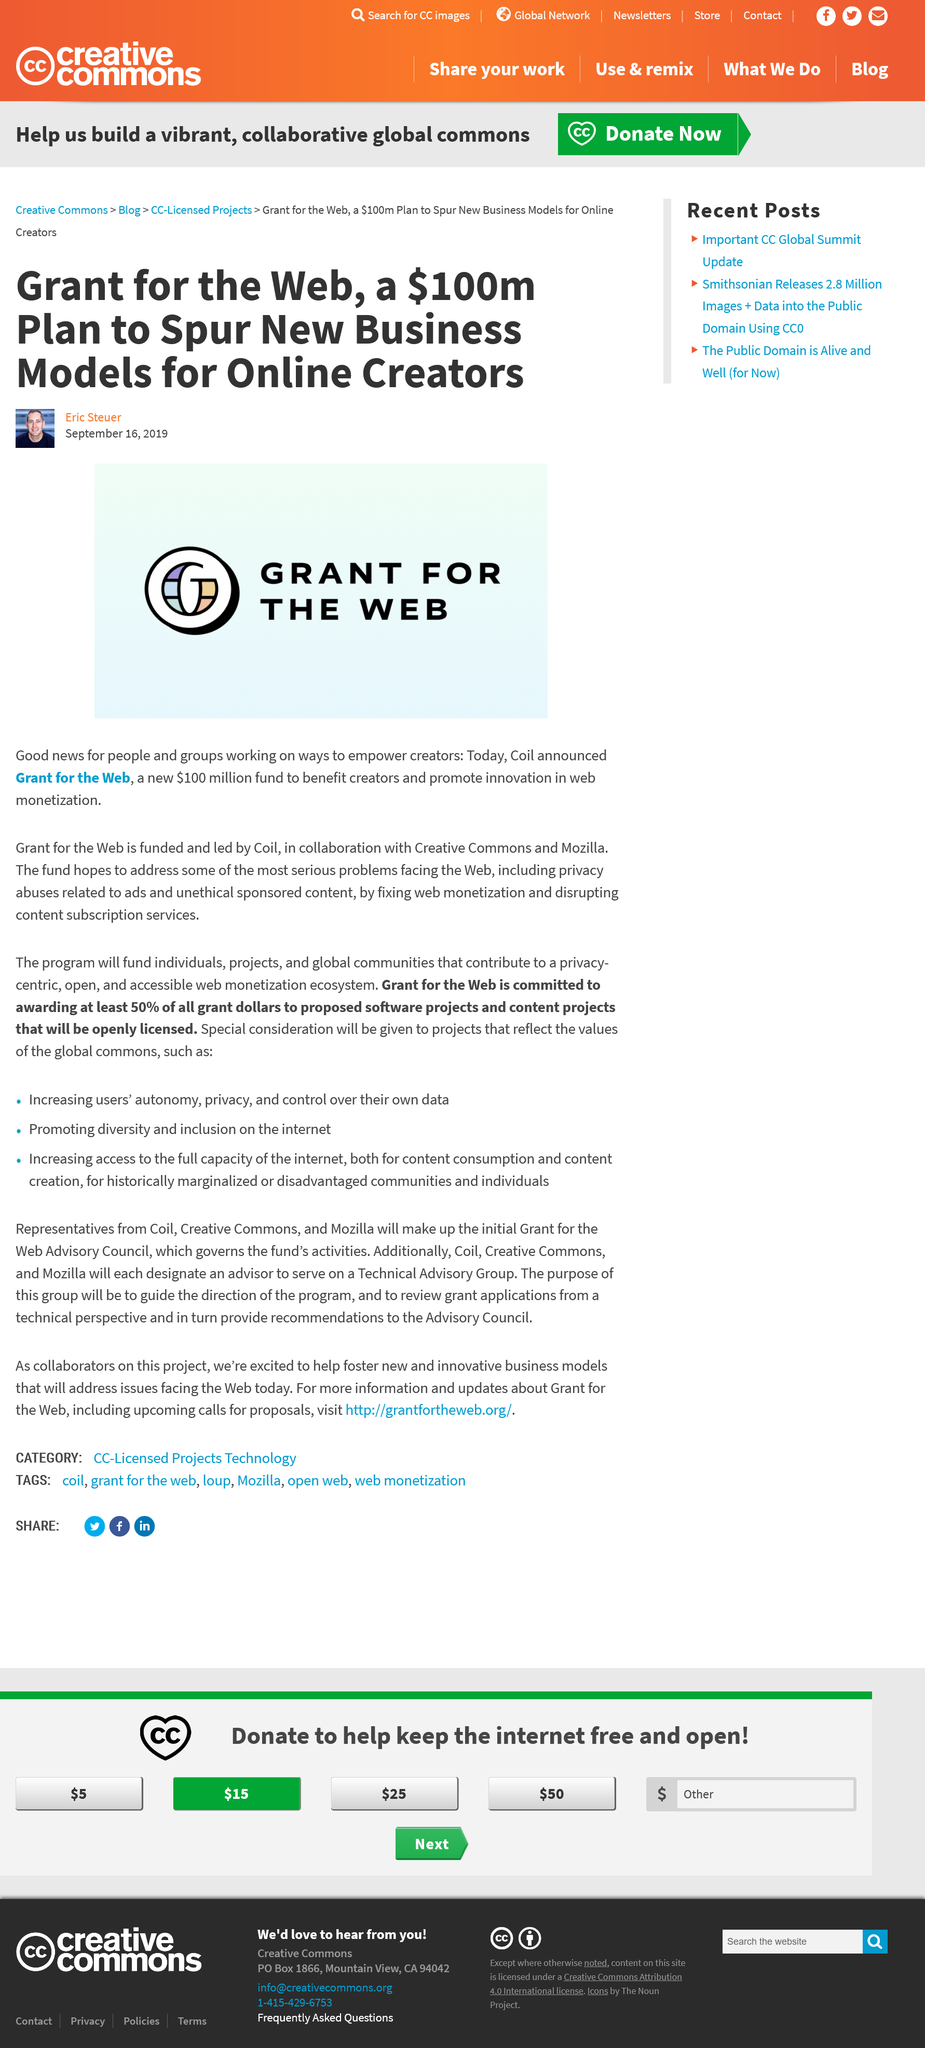Indicate a few pertinent items in this graphic. The $100 million fund is aimed at addressing the serious problems facing the web. Coil is the primary funder and leader of the Grant for the Web initiative. Coil collaborated with Creative Commons and Mozilla for the funding, and they collaborated with Who for the fund. 